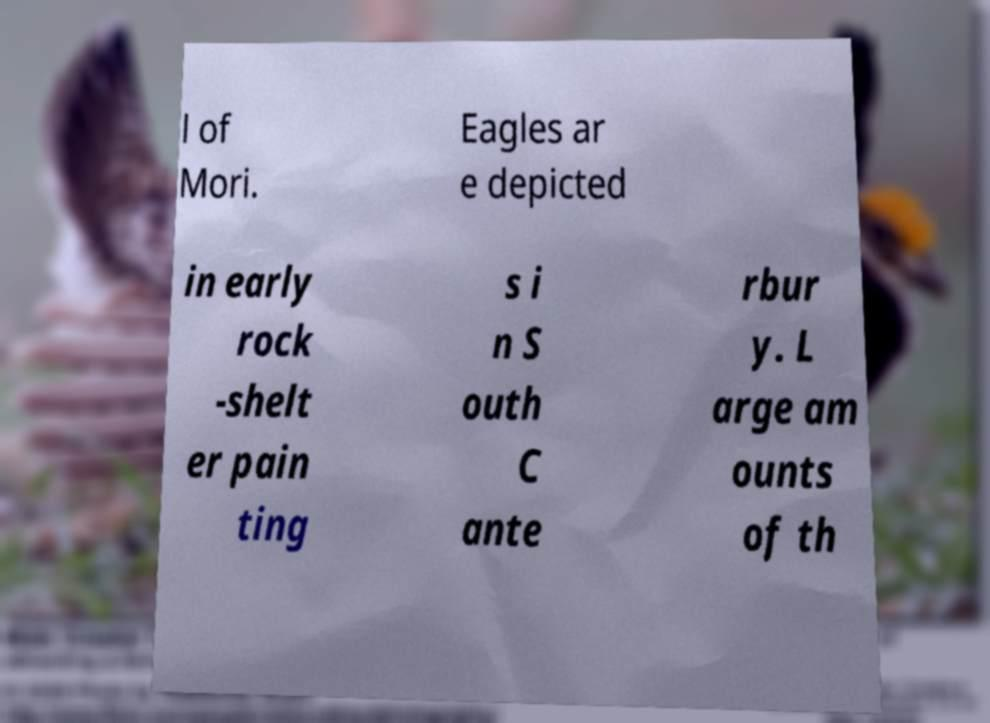Can you accurately transcribe the text from the provided image for me? l of Mori. Eagles ar e depicted in early rock -shelt er pain ting s i n S outh C ante rbur y. L arge am ounts of th 